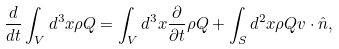<formula> <loc_0><loc_0><loc_500><loc_500>\frac { d } { d t } \int _ { V } d ^ { 3 } x \rho Q = \int _ { V } d ^ { 3 } x \frac { \partial } { \partial t } \rho Q + \int _ { S } d ^ { 2 } x \rho Q v \cdot \hat { n } ,</formula> 